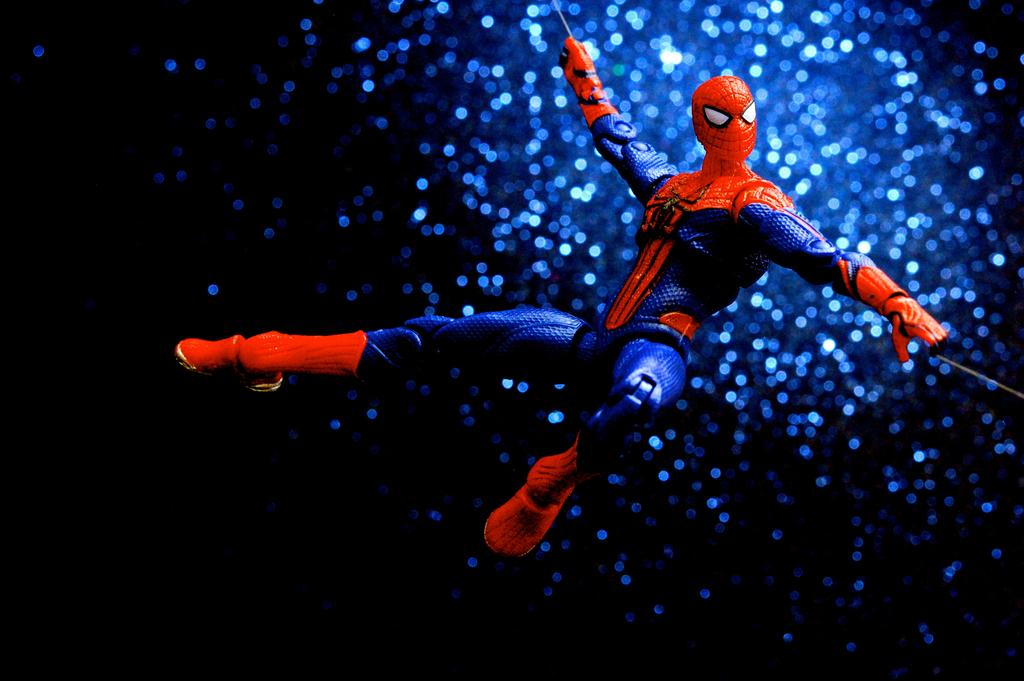What type of image is this? The image is animated. What is the color of the background in the image? The background of the image is dark. What can be seen in the image besides the dark background? There are blue sparkles in the image. Who or what is the main character in the image? There is a Spider-Man character in the middle of the image. How many chairs are visible in the image? There are no chairs present in the image. What type of poison is being used by the Spider-Man character in the image? The Spider-Man character in the image is not using any poison, as Spider-Man does not use poison in his superhero abilities. 